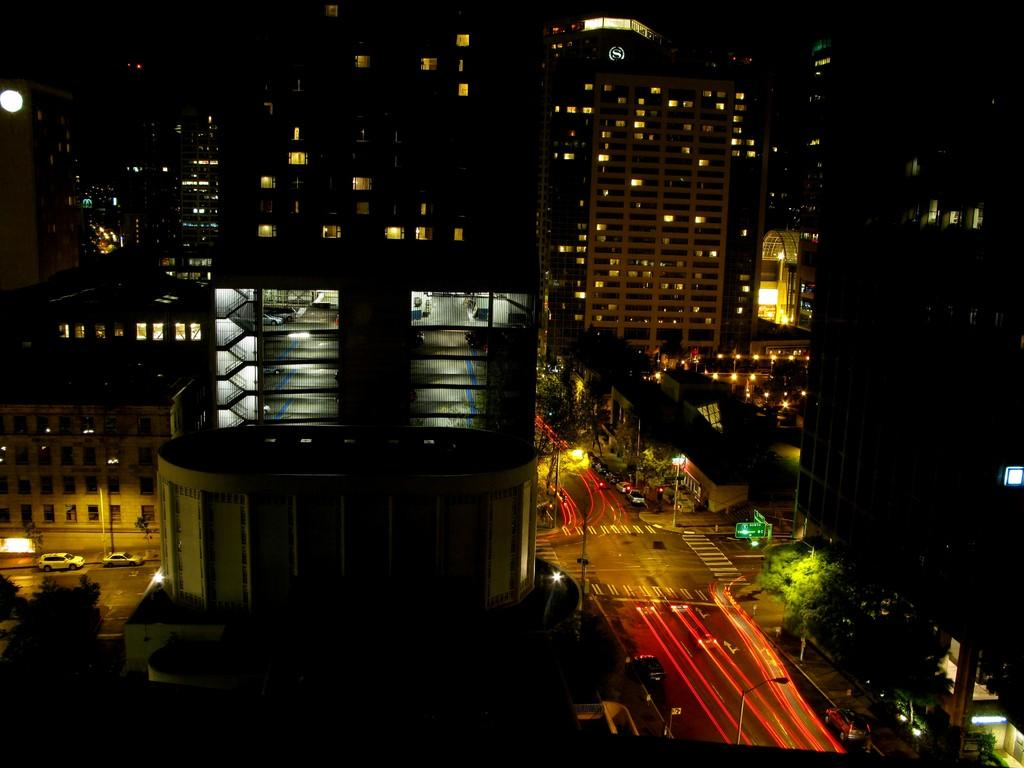Where was the picture taken? The picture was taken outside. What can be seen on the right side of the image? There are vehicles running on the road on the right side of the image. What type of natural elements are visible in the image? There are trees visible in the image. What type of man-made structures can be seen in the image? There are buildings in the image. What type of illumination is visible in the image? There are lights visible in the image. What type of umbrella is being used by the feeling in the image? There is no mention of a feeling or an umbrella in the image; it features vehicles, trees, buildings, and lights. 